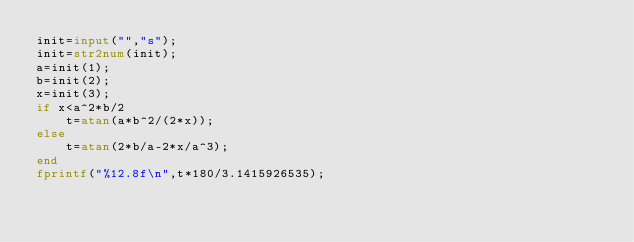<code> <loc_0><loc_0><loc_500><loc_500><_Octave_>init=input("","s");
init=str2num(init);
a=init(1);
b=init(2);
x=init(3);
if x<a^2*b/2
    t=atan(a*b^2/(2*x));
else
    t=atan(2*b/a-2*x/a^3);
end
fprintf("%12.8f\n",t*180/3.1415926535);</code> 